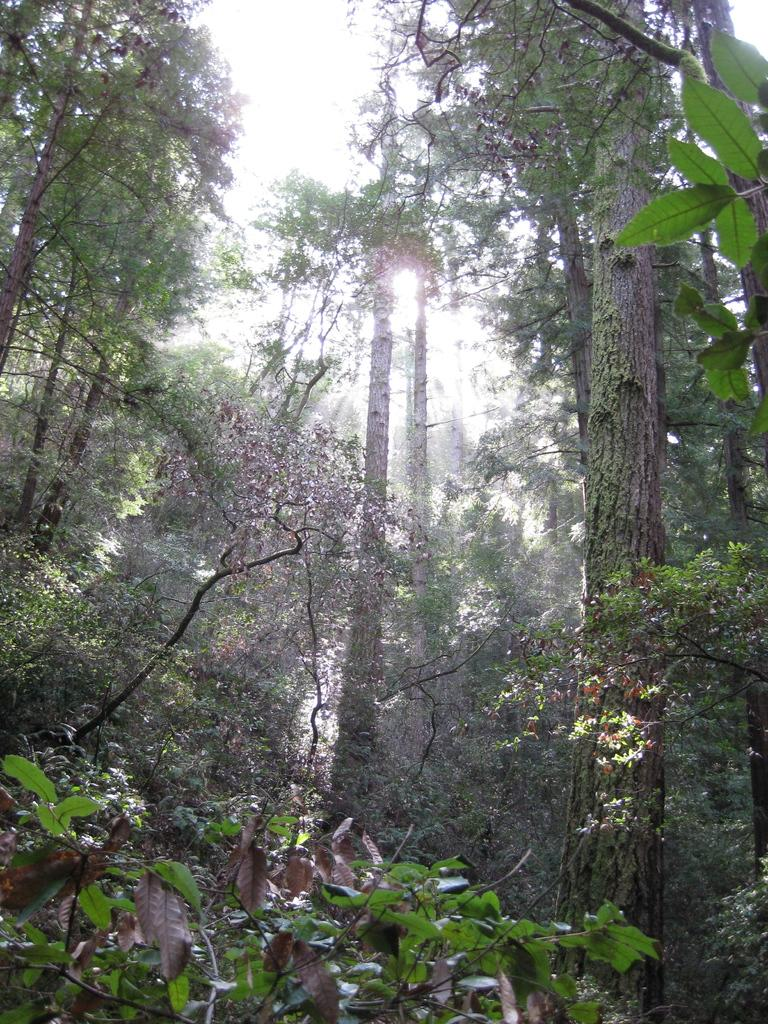What is located in the center of the image? There are trees in the center of the image. What can be seen in the background of the image? The sky is visible in the background of the image. What type of jam is being spread on the goose in the image? There is no goose or jam present in the image; it only features trees and the sky. 